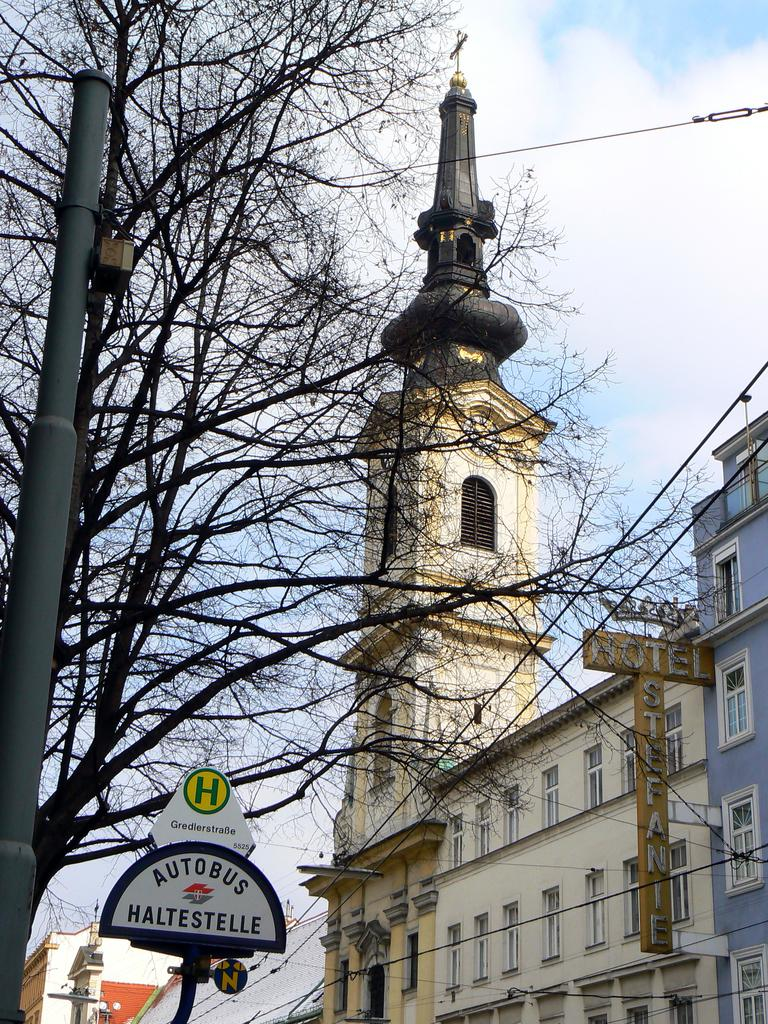What is located on the left side of the image? There is a tree and a pole on the left side of the image. What is at the bottom side of the image? There is a sign pole at the bottom side of the image. What can be seen in the background of the image? There are buildings, a wire, and the sky visible in the background of the image. Can you hear the sound of the ocean at the seashore in the image? There is no seashore or ocean present in the image; it features a tree, a pole, a sign pole, buildings, a wire, and the sky. What is the reaction of the hydrant in the image? There is no hydrant present in the image, so it is not possible to determine its reaction. 